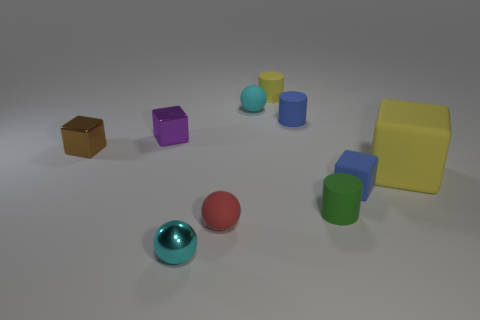Subtract all balls. How many objects are left? 7 Subtract 2 cyan balls. How many objects are left? 8 Subtract all small shiny things. Subtract all green things. How many objects are left? 6 Add 2 blue cylinders. How many blue cylinders are left? 3 Add 3 small matte spheres. How many small matte spheres exist? 5 